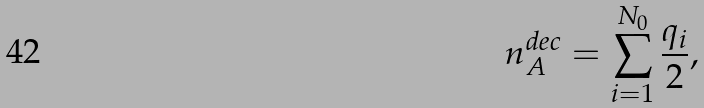Convert formula to latex. <formula><loc_0><loc_0><loc_500><loc_500>n _ { A } ^ { d e c } = \sum _ { i = 1 } ^ { N _ { 0 } } \frac { q _ { i } } { 2 } ,</formula> 